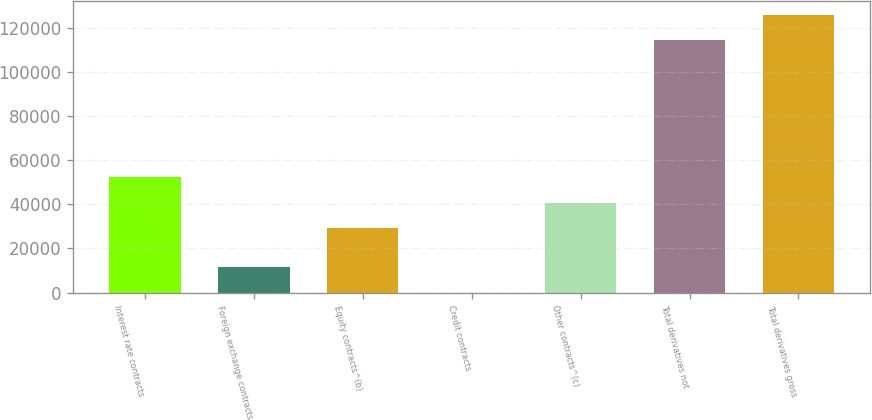Convert chart to OTSL. <chart><loc_0><loc_0><loc_500><loc_500><bar_chart><fcel>Interest rate contracts<fcel>Foreign exchange contracts<fcel>Equity contracts^(b)<fcel>Credit contracts<fcel>Other contracts^(c)<fcel>Total derivatives not<fcel>Total derivatives gross<nl><fcel>52180.8<fcel>11512.4<fcel>29296<fcel>70<fcel>40738.4<fcel>114494<fcel>125936<nl></chart> 